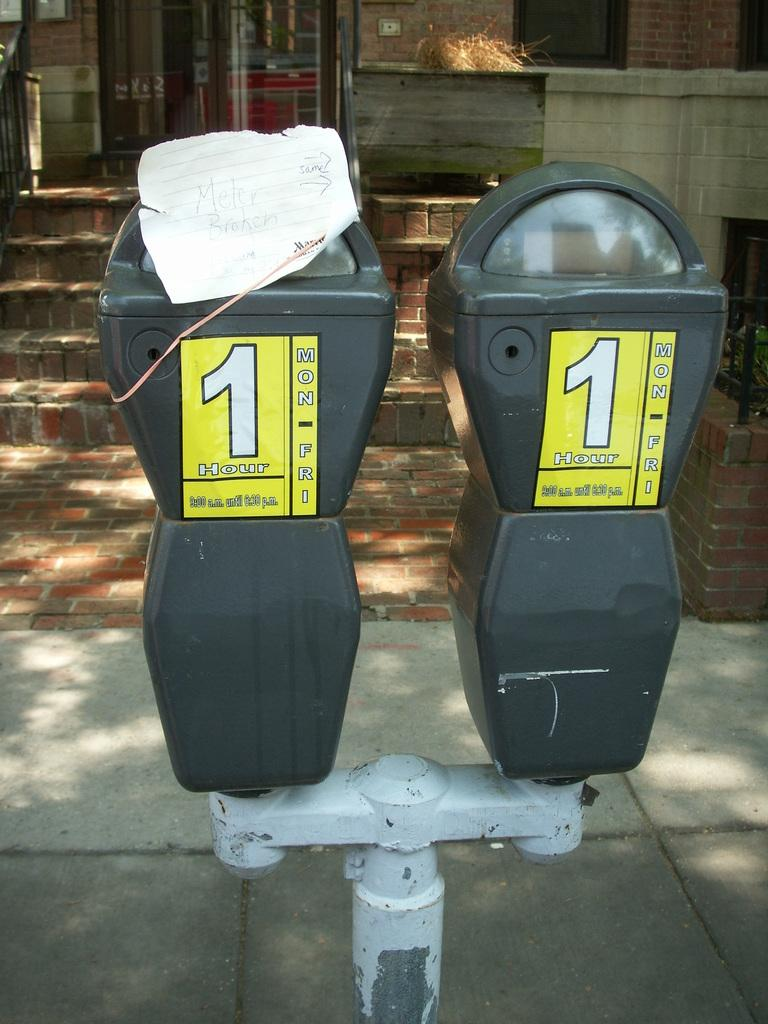<image>
Give a short and clear explanation of the subsequent image. Someone has placed a hand-written note on a parking meter that says "meter broken". 